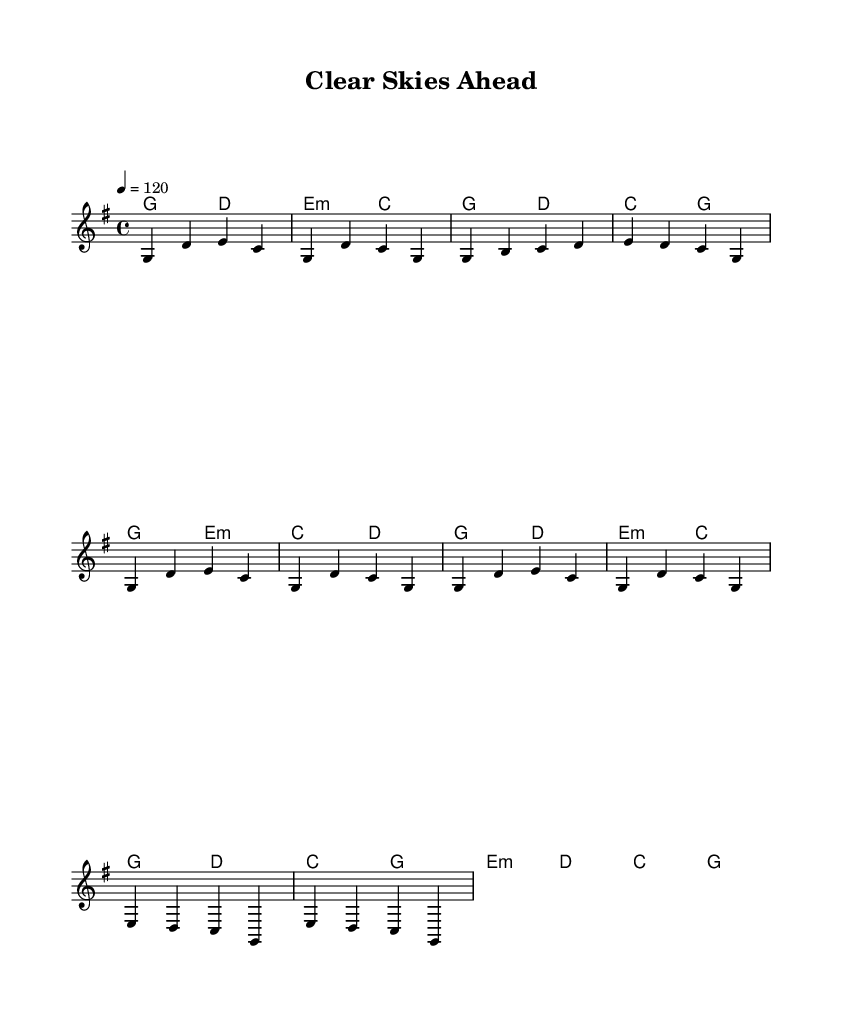What is the key signature of this music? The key signature is G major, which has one sharp (F#). This can be identified by looking at the beginning of the sheet music where the key signature is indicated.
Answer: G major What is the time signature? The time signature is 4/4, which means there are four beats in each measure and a quarter note gets one beat. This is indicated near the start of the sheet music.
Answer: 4/4 What is the tempo marking? The tempo is marked as 120 beats per minute, indicated at the beginning. It suggests the intended speed of the piece.
Answer: 120 How many measures are in the chorus? The chorus section contains four measures, which can be counted from the corresponding section of the melody. Each group of notes separated by vertical lines represents a measure.
Answer: 4 What is the first lyric of the verse? The first lyric of the verse is "Woke up this morning." This can be found at the beginning of the lyric section under the melody.
Answer: Woke up this morning What chord follows the first measure of the bridge? The chord that follows the first measure of the bridge is E minor. This is identified in the chord symbols indicated above the staff during the bridge part of the song.
Answer: E minor What is the overall theme of the song? The overall theme of the song is sobriety and clean living. This can be inferred from the lyrics that emphasize feeling rejuvenated and clear-headed.
Answer: Sobriety 